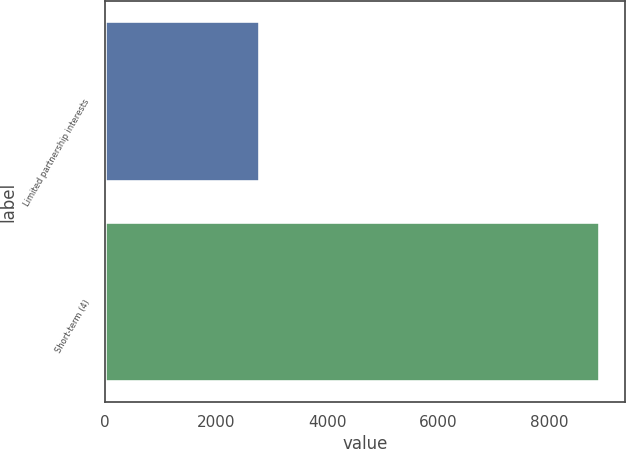<chart> <loc_0><loc_0><loc_500><loc_500><bar_chart><fcel>Limited partnership interests<fcel>Short-term (4)<nl><fcel>2791<fcel>8906<nl></chart> 